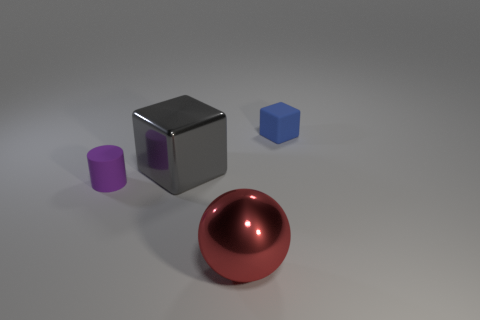There is a red shiny thing that is to the right of the small purple cylinder to the left of the large metal thing that is in front of the purple cylinder; what is its size?
Give a very brief answer. Large. What number of other objects are the same size as the blue cube?
Offer a very short reply. 1. What number of other purple cylinders have the same material as the tiny purple cylinder?
Provide a short and direct response. 0. What shape is the tiny rubber object in front of the tiny rubber cube?
Offer a very short reply. Cylinder. Do the tiny cylinder and the cube to the left of the red metallic sphere have the same material?
Your answer should be compact. No. Is there a large gray metallic thing?
Keep it short and to the point. Yes. There is a tiny matte object on the left side of the small blue rubber thing to the right of the small purple thing; is there a cube that is to the right of it?
Make the answer very short. Yes. How many big things are either rubber things or brown matte cylinders?
Your response must be concise. 0. What is the color of the metallic cube that is the same size as the sphere?
Provide a succinct answer. Gray. There is a big shiny block; what number of big gray metallic objects are in front of it?
Keep it short and to the point. 0. 